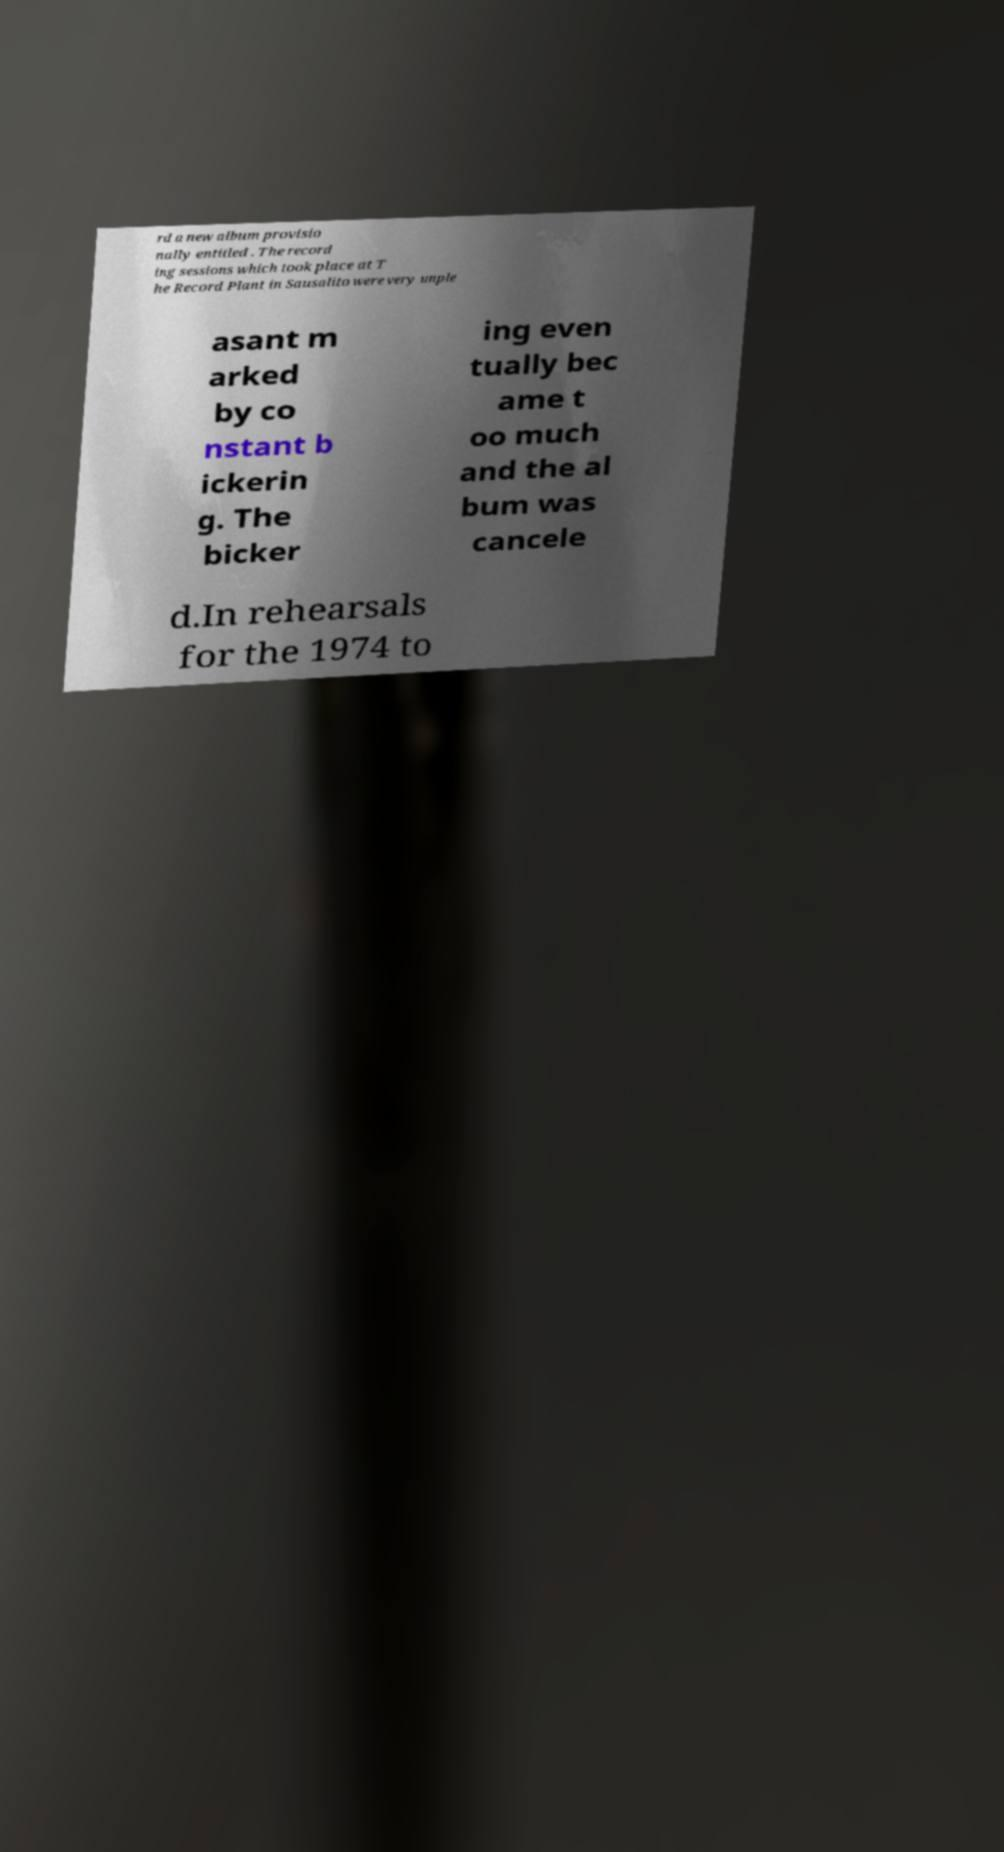For documentation purposes, I need the text within this image transcribed. Could you provide that? rd a new album provisio nally entitled . The record ing sessions which took place at T he Record Plant in Sausalito were very unple asant m arked by co nstant b ickerin g. The bicker ing even tually bec ame t oo much and the al bum was cancele d.In rehearsals for the 1974 to 